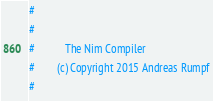<code> <loc_0><loc_0><loc_500><loc_500><_Nim_>#
#
#           The Nim Compiler
#        (c) Copyright 2015 Andreas Rumpf
#</code> 